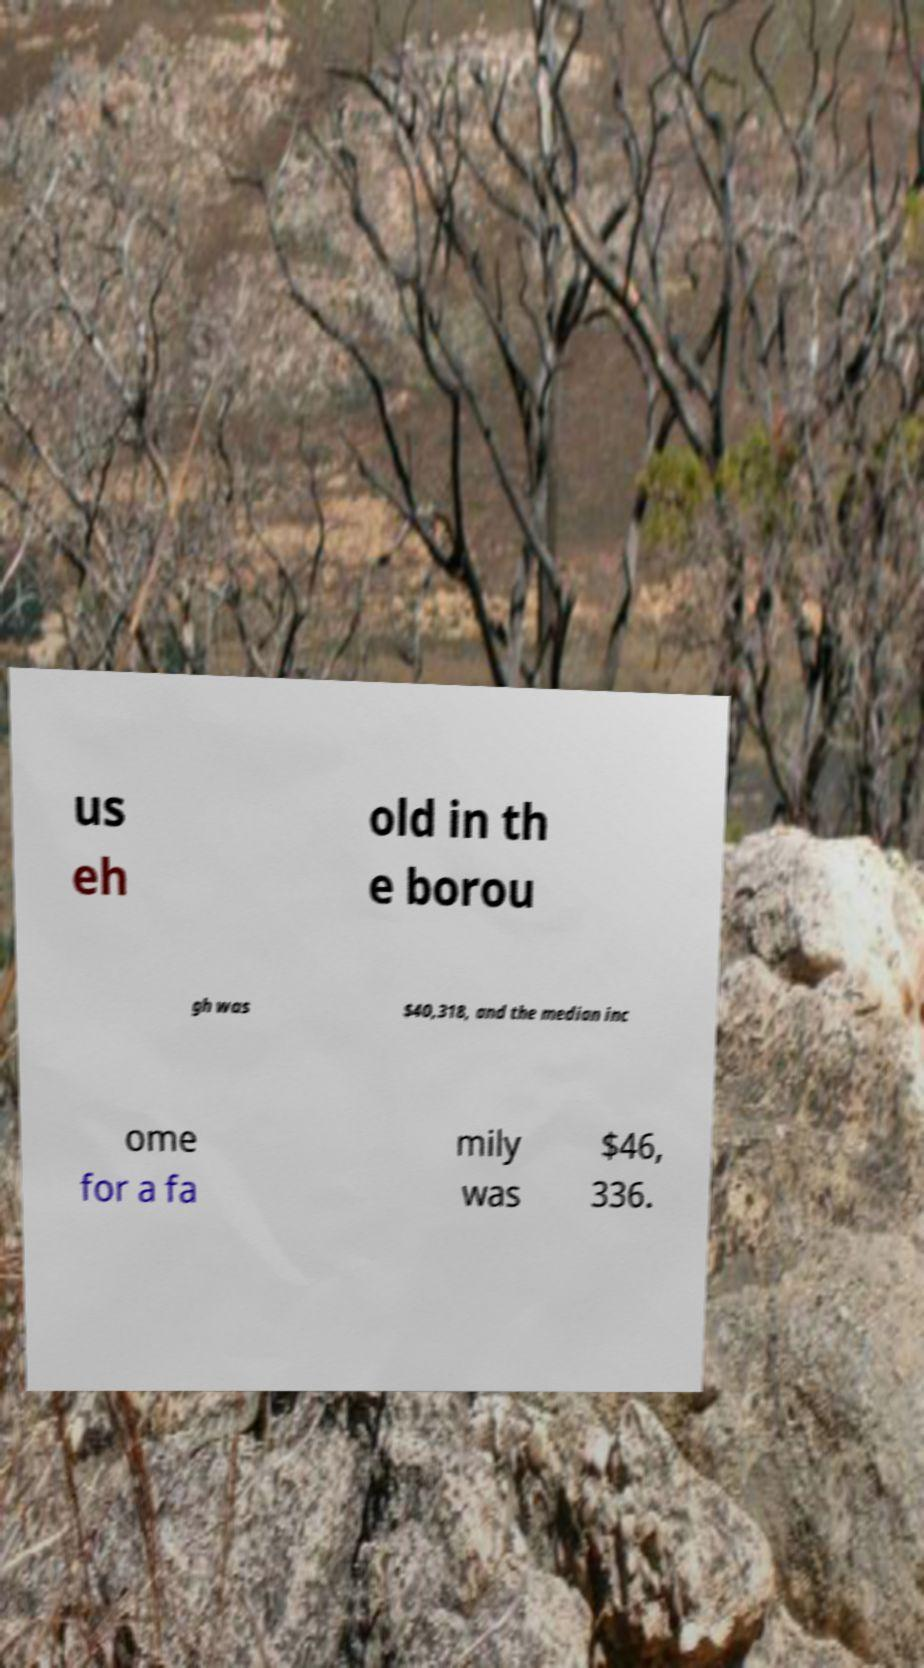What messages or text are displayed in this image? I need them in a readable, typed format. us eh old in th e borou gh was $40,318, and the median inc ome for a fa mily was $46, 336. 